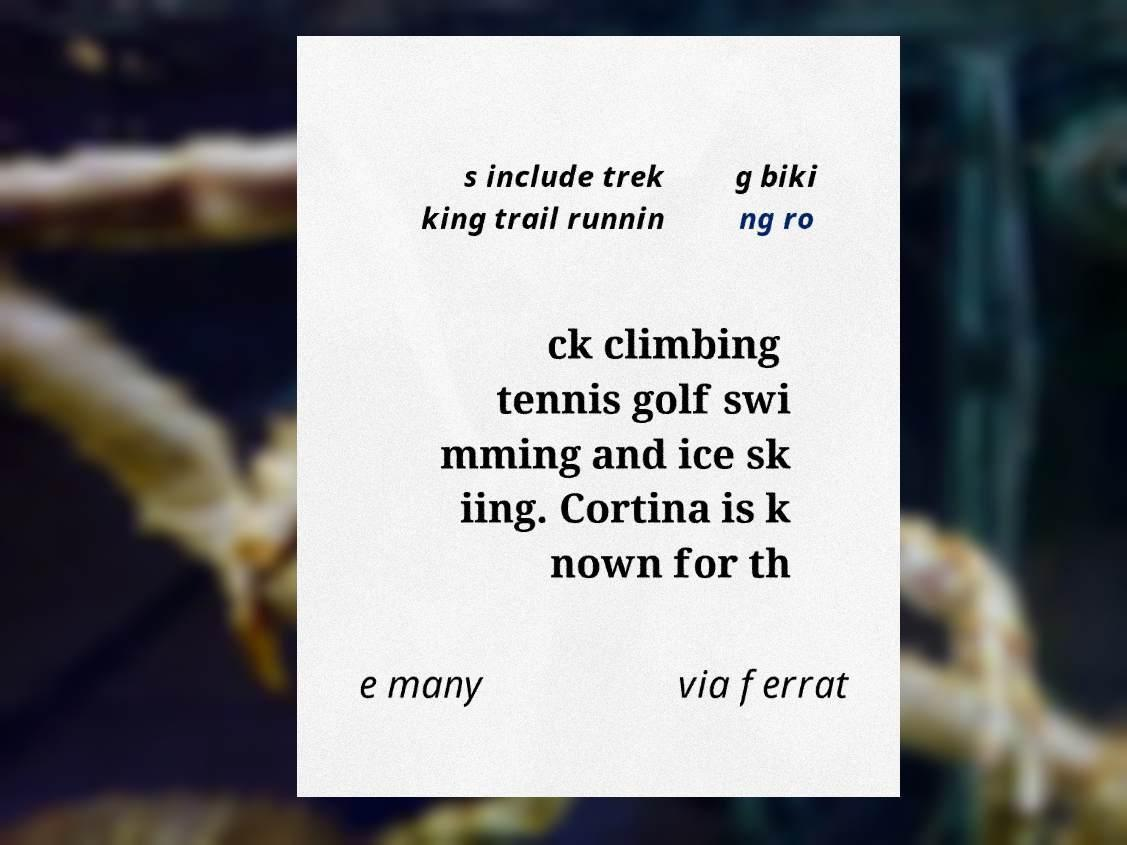Please read and relay the text visible in this image. What does it say? s include trek king trail runnin g biki ng ro ck climbing tennis golf swi mming and ice sk iing. Cortina is k nown for th e many via ferrat 